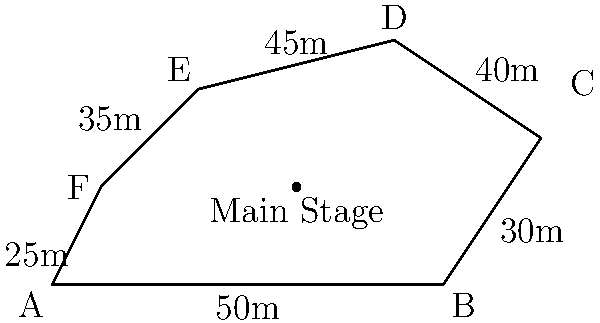As the CEO of a record label exploring jazz fusion's commercial potential, you're planning a music festival. The irregular-shaped festival grounds are shown above, with the lengths of each side provided. If you need to calculate the area to determine the maximum capacity for ticket sales, what is the total area of the festival grounds in square meters? To find the area of this irregular shape, we can use the following steps:

1. Divide the shape into triangles:
   Triangle 1: ABF
   Triangle 2: BCF
   Triangle 3: CDF
   Triangle 4: DEF

2. Calculate the area of each triangle using Heron's formula:
   $A = \sqrt{s(s-a)(s-b)(s-c)}$
   where $s = \frac{a+b+c}{2}$ (half-perimeter) and $a$, $b$, $c$ are the side lengths.

3. For Triangle ABF:
   $a = 50$, $b = 25$, $c = \sqrt{1^2 + 2^2} = \sqrt{5} \approx 2.24$
   $s = \frac{50 + 25 + 2.24}{2} = 38.62$
   $A_1 = \sqrt{38.62(38.62-50)(38.62-25)(38.62-2.24)} \approx 56.18$ m²

4. For Triangle BCF:
   $a = 30$, $b = \sqrt{2^2 + 3^2} = \sqrt{13} \approx 3.61$, $c = \sqrt{7^2 + 2^2} = \sqrt{53} \approx 7.28$
   $s = \frac{30 + 3.61 + 7.28}{2} = 20.45$
   $A_2 = \sqrt{20.45(20.45-30)(20.45-3.61)(20.45-7.28)} \approx 10.84$ m²

5. For Triangle CDF:
   $a = 40$, $b = \sqrt{3^2 + 2^2} = \sqrt{13} \approx 3.61$, $c = \sqrt{9^2 + 3^2} = \sqrt{90} \approx 9.49$
   $s = \frac{40 + 3.61 + 9.49}{2} = 26.55$
   $A_3 = \sqrt{26.55(26.55-40)(26.55-3.61)(26.55-9.49)} \approx 16.31$ m²

6. For Triangle DEF:
   $a = 45$, $b = 35$, $c = \sqrt{4^2 + 2^2} = \sqrt{20} \approx 4.47$
   $s = \frac{45 + 35 + 4.47}{2} = 42.24$
   $A_4 = \sqrt{42.24(42.24-45)(42.24-35)(42.24-4.47)} \approx 78.54$ m²

7. Sum up all triangle areas:
   Total Area = $A_1 + A_2 + A_3 + A_4$
               $\approx 56.18 + 10.84 + 16.31 + 78.54$
               $\approx 161.87$ m²
Answer: 161.87 m² 